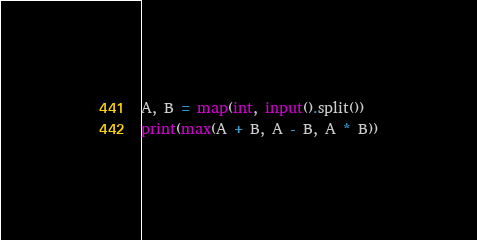<code> <loc_0><loc_0><loc_500><loc_500><_Python_>A, B = map(int, input().split())
print(max(A + B, A - B, A * B))</code> 